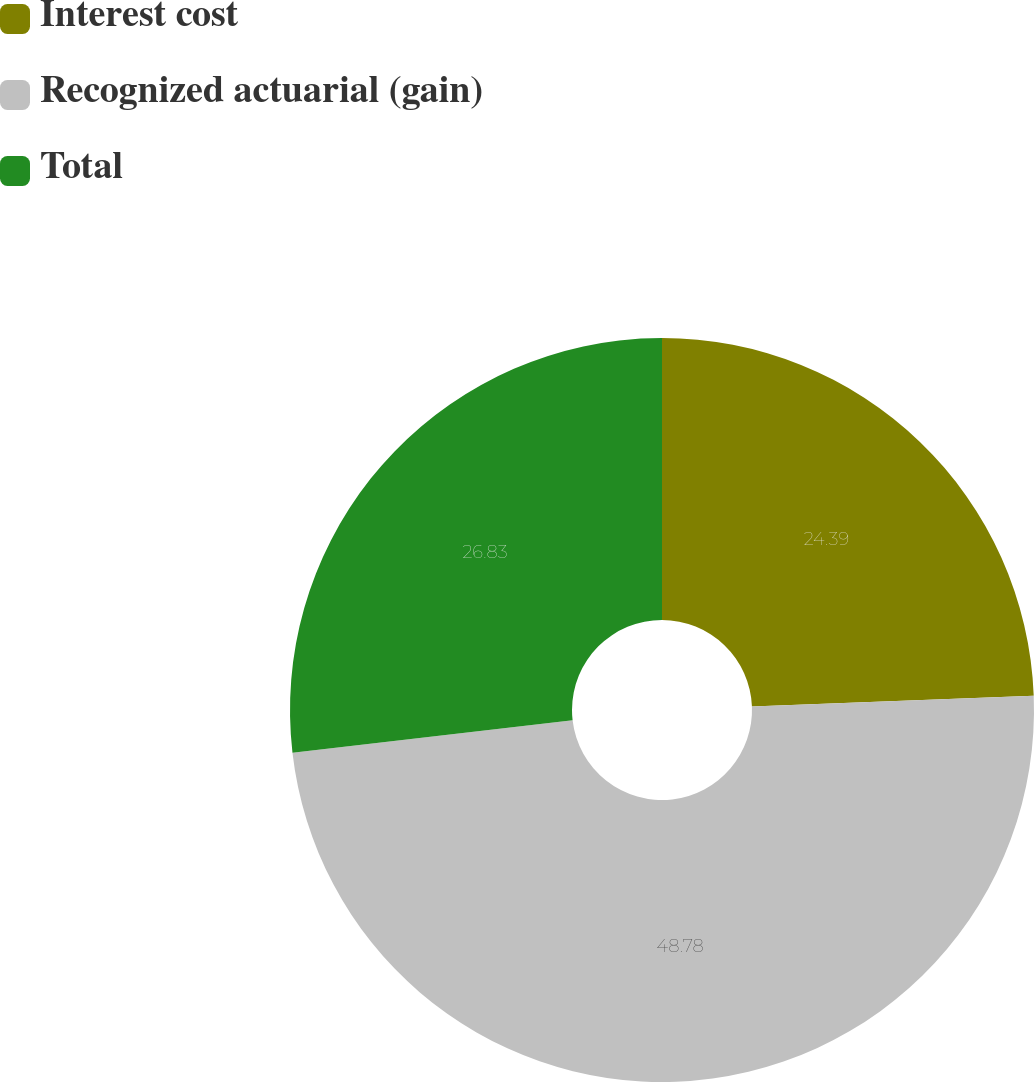Convert chart. <chart><loc_0><loc_0><loc_500><loc_500><pie_chart><fcel>Interest cost<fcel>Recognized actuarial (gain)<fcel>Total<nl><fcel>24.39%<fcel>48.78%<fcel>26.83%<nl></chart> 